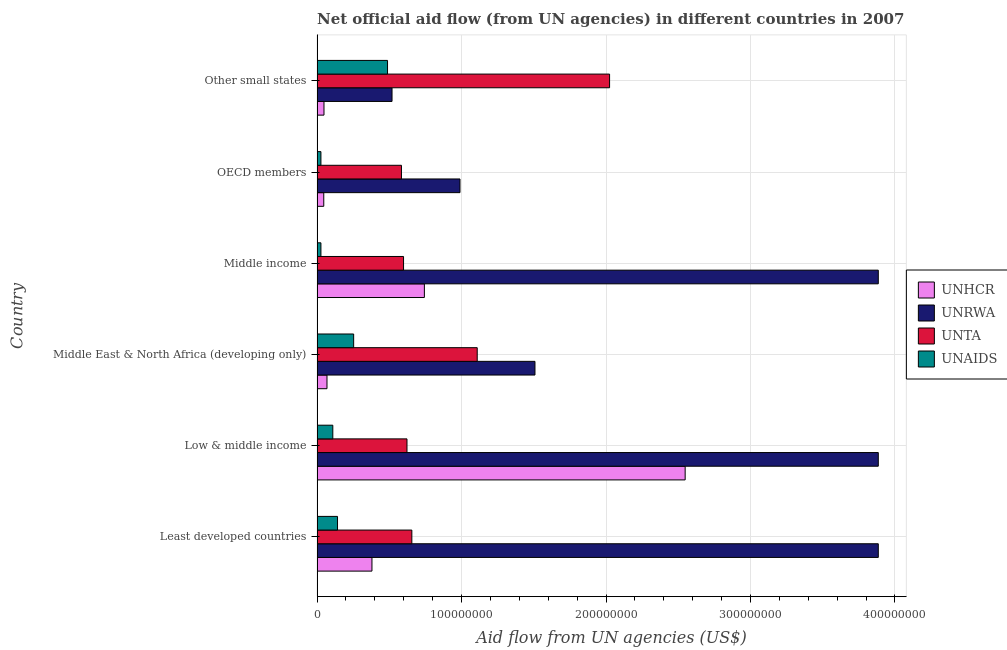How many different coloured bars are there?
Provide a short and direct response. 4. How many bars are there on the 4th tick from the top?
Your answer should be compact. 4. How many bars are there on the 6th tick from the bottom?
Provide a succinct answer. 4. What is the label of the 4th group of bars from the top?
Provide a short and direct response. Middle East & North Africa (developing only). What is the amount of aid given by unrwa in Low & middle income?
Provide a succinct answer. 3.88e+08. Across all countries, what is the maximum amount of aid given by unaids?
Give a very brief answer. 4.88e+07. Across all countries, what is the minimum amount of aid given by unta?
Your response must be concise. 5.84e+07. In which country was the amount of aid given by unrwa maximum?
Provide a short and direct response. Least developed countries. What is the total amount of aid given by unhcr in the graph?
Your response must be concise. 3.83e+08. What is the difference between the amount of aid given by unta in Middle East & North Africa (developing only) and that in Middle income?
Ensure brevity in your answer.  5.10e+07. What is the difference between the amount of aid given by unhcr in Low & middle income and the amount of aid given by unaids in Other small states?
Provide a succinct answer. 2.06e+08. What is the average amount of aid given by unta per country?
Provide a short and direct response. 9.32e+07. What is the difference between the amount of aid given by unta and amount of aid given by unrwa in Low & middle income?
Keep it short and to the point. -3.26e+08. What is the ratio of the amount of aid given by unrwa in Least developed countries to that in Middle income?
Your answer should be compact. 1. Is the difference between the amount of aid given by unrwa in Least developed countries and Middle income greater than the difference between the amount of aid given by unaids in Least developed countries and Middle income?
Give a very brief answer. No. What is the difference between the highest and the second highest amount of aid given by unaids?
Offer a terse response. 2.34e+07. What is the difference between the highest and the lowest amount of aid given by unaids?
Your answer should be very brief. 4.61e+07. Is it the case that in every country, the sum of the amount of aid given by unhcr and amount of aid given by unrwa is greater than the sum of amount of aid given by unaids and amount of aid given by unta?
Provide a succinct answer. Yes. What does the 3rd bar from the top in Middle East & North Africa (developing only) represents?
Give a very brief answer. UNRWA. What does the 2nd bar from the bottom in Least developed countries represents?
Provide a short and direct response. UNRWA. How many bars are there?
Offer a terse response. 24. Are the values on the major ticks of X-axis written in scientific E-notation?
Make the answer very short. No. Does the graph contain any zero values?
Keep it short and to the point. No. Where does the legend appear in the graph?
Your answer should be very brief. Center right. How many legend labels are there?
Make the answer very short. 4. How are the legend labels stacked?
Provide a succinct answer. Vertical. What is the title of the graph?
Make the answer very short. Net official aid flow (from UN agencies) in different countries in 2007. Does "Salary of employees" appear as one of the legend labels in the graph?
Ensure brevity in your answer.  No. What is the label or title of the X-axis?
Offer a terse response. Aid flow from UN agencies (US$). What is the label or title of the Y-axis?
Make the answer very short. Country. What is the Aid flow from UN agencies (US$) of UNHCR in Least developed countries?
Your response must be concise. 3.80e+07. What is the Aid flow from UN agencies (US$) in UNRWA in Least developed countries?
Provide a short and direct response. 3.88e+08. What is the Aid flow from UN agencies (US$) of UNTA in Least developed countries?
Your answer should be very brief. 6.56e+07. What is the Aid flow from UN agencies (US$) in UNAIDS in Least developed countries?
Offer a terse response. 1.42e+07. What is the Aid flow from UN agencies (US$) of UNHCR in Low & middle income?
Ensure brevity in your answer.  2.55e+08. What is the Aid flow from UN agencies (US$) in UNRWA in Low & middle income?
Your response must be concise. 3.88e+08. What is the Aid flow from UN agencies (US$) in UNTA in Low & middle income?
Your response must be concise. 6.22e+07. What is the Aid flow from UN agencies (US$) in UNAIDS in Low & middle income?
Provide a succinct answer. 1.09e+07. What is the Aid flow from UN agencies (US$) of UNHCR in Middle East & North Africa (developing only)?
Your answer should be compact. 6.87e+06. What is the Aid flow from UN agencies (US$) of UNRWA in Middle East & North Africa (developing only)?
Keep it short and to the point. 1.51e+08. What is the Aid flow from UN agencies (US$) in UNTA in Middle East & North Africa (developing only)?
Your response must be concise. 1.11e+08. What is the Aid flow from UN agencies (US$) in UNAIDS in Middle East & North Africa (developing only)?
Ensure brevity in your answer.  2.53e+07. What is the Aid flow from UN agencies (US$) in UNHCR in Middle income?
Provide a short and direct response. 7.43e+07. What is the Aid flow from UN agencies (US$) of UNRWA in Middle income?
Make the answer very short. 3.88e+08. What is the Aid flow from UN agencies (US$) in UNTA in Middle income?
Give a very brief answer. 5.99e+07. What is the Aid flow from UN agencies (US$) of UNAIDS in Middle income?
Keep it short and to the point. 2.68e+06. What is the Aid flow from UN agencies (US$) of UNHCR in OECD members?
Offer a very short reply. 4.65e+06. What is the Aid flow from UN agencies (US$) of UNRWA in OECD members?
Offer a terse response. 9.89e+07. What is the Aid flow from UN agencies (US$) of UNTA in OECD members?
Ensure brevity in your answer.  5.84e+07. What is the Aid flow from UN agencies (US$) of UNAIDS in OECD members?
Give a very brief answer. 2.68e+06. What is the Aid flow from UN agencies (US$) of UNHCR in Other small states?
Your answer should be compact. 4.80e+06. What is the Aid flow from UN agencies (US$) in UNRWA in Other small states?
Your answer should be compact. 5.19e+07. What is the Aid flow from UN agencies (US$) of UNTA in Other small states?
Offer a terse response. 2.02e+08. What is the Aid flow from UN agencies (US$) of UNAIDS in Other small states?
Your answer should be very brief. 4.88e+07. Across all countries, what is the maximum Aid flow from UN agencies (US$) in UNHCR?
Ensure brevity in your answer.  2.55e+08. Across all countries, what is the maximum Aid flow from UN agencies (US$) of UNRWA?
Your response must be concise. 3.88e+08. Across all countries, what is the maximum Aid flow from UN agencies (US$) in UNTA?
Provide a succinct answer. 2.02e+08. Across all countries, what is the maximum Aid flow from UN agencies (US$) of UNAIDS?
Your answer should be very brief. 4.88e+07. Across all countries, what is the minimum Aid flow from UN agencies (US$) in UNHCR?
Make the answer very short. 4.65e+06. Across all countries, what is the minimum Aid flow from UN agencies (US$) in UNRWA?
Give a very brief answer. 5.19e+07. Across all countries, what is the minimum Aid flow from UN agencies (US$) in UNTA?
Offer a terse response. 5.84e+07. Across all countries, what is the minimum Aid flow from UN agencies (US$) in UNAIDS?
Provide a succinct answer. 2.68e+06. What is the total Aid flow from UN agencies (US$) of UNHCR in the graph?
Offer a terse response. 3.83e+08. What is the total Aid flow from UN agencies (US$) in UNRWA in the graph?
Make the answer very short. 1.47e+09. What is the total Aid flow from UN agencies (US$) of UNTA in the graph?
Your answer should be compact. 5.59e+08. What is the total Aid flow from UN agencies (US$) of UNAIDS in the graph?
Provide a short and direct response. 1.05e+08. What is the difference between the Aid flow from UN agencies (US$) of UNHCR in Least developed countries and that in Low & middle income?
Make the answer very short. -2.17e+08. What is the difference between the Aid flow from UN agencies (US$) of UNRWA in Least developed countries and that in Low & middle income?
Your response must be concise. 0. What is the difference between the Aid flow from UN agencies (US$) of UNTA in Least developed countries and that in Low & middle income?
Offer a terse response. 3.37e+06. What is the difference between the Aid flow from UN agencies (US$) of UNAIDS in Least developed countries and that in Low & middle income?
Offer a very short reply. 3.25e+06. What is the difference between the Aid flow from UN agencies (US$) in UNHCR in Least developed countries and that in Middle East & North Africa (developing only)?
Ensure brevity in your answer.  3.11e+07. What is the difference between the Aid flow from UN agencies (US$) of UNRWA in Least developed countries and that in Middle East & North Africa (developing only)?
Make the answer very short. 2.38e+08. What is the difference between the Aid flow from UN agencies (US$) of UNTA in Least developed countries and that in Middle East & North Africa (developing only)?
Offer a very short reply. -4.52e+07. What is the difference between the Aid flow from UN agencies (US$) in UNAIDS in Least developed countries and that in Middle East & North Africa (developing only)?
Give a very brief answer. -1.12e+07. What is the difference between the Aid flow from UN agencies (US$) in UNHCR in Least developed countries and that in Middle income?
Keep it short and to the point. -3.63e+07. What is the difference between the Aid flow from UN agencies (US$) of UNRWA in Least developed countries and that in Middle income?
Give a very brief answer. 0. What is the difference between the Aid flow from UN agencies (US$) of UNTA in Least developed countries and that in Middle income?
Offer a terse response. 5.75e+06. What is the difference between the Aid flow from UN agencies (US$) in UNAIDS in Least developed countries and that in Middle income?
Make the answer very short. 1.15e+07. What is the difference between the Aid flow from UN agencies (US$) in UNHCR in Least developed countries and that in OECD members?
Ensure brevity in your answer.  3.34e+07. What is the difference between the Aid flow from UN agencies (US$) in UNRWA in Least developed countries and that in OECD members?
Provide a succinct answer. 2.90e+08. What is the difference between the Aid flow from UN agencies (US$) in UNTA in Least developed countries and that in OECD members?
Provide a short and direct response. 7.20e+06. What is the difference between the Aid flow from UN agencies (US$) of UNAIDS in Least developed countries and that in OECD members?
Provide a short and direct response. 1.15e+07. What is the difference between the Aid flow from UN agencies (US$) in UNHCR in Least developed countries and that in Other small states?
Make the answer very short. 3.32e+07. What is the difference between the Aid flow from UN agencies (US$) in UNRWA in Least developed countries and that in Other small states?
Your answer should be very brief. 3.37e+08. What is the difference between the Aid flow from UN agencies (US$) of UNTA in Least developed countries and that in Other small states?
Offer a terse response. -1.37e+08. What is the difference between the Aid flow from UN agencies (US$) in UNAIDS in Least developed countries and that in Other small states?
Your response must be concise. -3.46e+07. What is the difference between the Aid flow from UN agencies (US$) of UNHCR in Low & middle income and that in Middle East & North Africa (developing only)?
Provide a short and direct response. 2.48e+08. What is the difference between the Aid flow from UN agencies (US$) in UNRWA in Low & middle income and that in Middle East & North Africa (developing only)?
Offer a very short reply. 2.38e+08. What is the difference between the Aid flow from UN agencies (US$) of UNTA in Low & middle income and that in Middle East & North Africa (developing only)?
Make the answer very short. -4.86e+07. What is the difference between the Aid flow from UN agencies (US$) of UNAIDS in Low & middle income and that in Middle East & North Africa (developing only)?
Your answer should be compact. -1.44e+07. What is the difference between the Aid flow from UN agencies (US$) in UNHCR in Low & middle income and that in Middle income?
Your response must be concise. 1.80e+08. What is the difference between the Aid flow from UN agencies (US$) of UNRWA in Low & middle income and that in Middle income?
Provide a short and direct response. 0. What is the difference between the Aid flow from UN agencies (US$) of UNTA in Low & middle income and that in Middle income?
Provide a succinct answer. 2.38e+06. What is the difference between the Aid flow from UN agencies (US$) in UNAIDS in Low & middle income and that in Middle income?
Offer a very short reply. 8.23e+06. What is the difference between the Aid flow from UN agencies (US$) of UNHCR in Low & middle income and that in OECD members?
Your response must be concise. 2.50e+08. What is the difference between the Aid flow from UN agencies (US$) of UNRWA in Low & middle income and that in OECD members?
Offer a terse response. 2.90e+08. What is the difference between the Aid flow from UN agencies (US$) in UNTA in Low & middle income and that in OECD members?
Offer a very short reply. 3.83e+06. What is the difference between the Aid flow from UN agencies (US$) in UNAIDS in Low & middle income and that in OECD members?
Offer a terse response. 8.23e+06. What is the difference between the Aid flow from UN agencies (US$) in UNHCR in Low & middle income and that in Other small states?
Give a very brief answer. 2.50e+08. What is the difference between the Aid flow from UN agencies (US$) of UNRWA in Low & middle income and that in Other small states?
Give a very brief answer. 3.37e+08. What is the difference between the Aid flow from UN agencies (US$) of UNTA in Low & middle income and that in Other small states?
Your response must be concise. -1.40e+08. What is the difference between the Aid flow from UN agencies (US$) in UNAIDS in Low & middle income and that in Other small states?
Your answer should be very brief. -3.79e+07. What is the difference between the Aid flow from UN agencies (US$) of UNHCR in Middle East & North Africa (developing only) and that in Middle income?
Give a very brief answer. -6.74e+07. What is the difference between the Aid flow from UN agencies (US$) in UNRWA in Middle East & North Africa (developing only) and that in Middle income?
Provide a short and direct response. -2.38e+08. What is the difference between the Aid flow from UN agencies (US$) of UNTA in Middle East & North Africa (developing only) and that in Middle income?
Your answer should be very brief. 5.10e+07. What is the difference between the Aid flow from UN agencies (US$) of UNAIDS in Middle East & North Africa (developing only) and that in Middle income?
Provide a short and direct response. 2.26e+07. What is the difference between the Aid flow from UN agencies (US$) in UNHCR in Middle East & North Africa (developing only) and that in OECD members?
Your response must be concise. 2.22e+06. What is the difference between the Aid flow from UN agencies (US$) of UNRWA in Middle East & North Africa (developing only) and that in OECD members?
Make the answer very short. 5.19e+07. What is the difference between the Aid flow from UN agencies (US$) of UNTA in Middle East & North Africa (developing only) and that in OECD members?
Ensure brevity in your answer.  5.24e+07. What is the difference between the Aid flow from UN agencies (US$) of UNAIDS in Middle East & North Africa (developing only) and that in OECD members?
Offer a terse response. 2.26e+07. What is the difference between the Aid flow from UN agencies (US$) of UNHCR in Middle East & North Africa (developing only) and that in Other small states?
Offer a very short reply. 2.07e+06. What is the difference between the Aid flow from UN agencies (US$) in UNRWA in Middle East & North Africa (developing only) and that in Other small states?
Your answer should be compact. 9.89e+07. What is the difference between the Aid flow from UN agencies (US$) in UNTA in Middle East & North Africa (developing only) and that in Other small states?
Provide a short and direct response. -9.16e+07. What is the difference between the Aid flow from UN agencies (US$) of UNAIDS in Middle East & North Africa (developing only) and that in Other small states?
Give a very brief answer. -2.34e+07. What is the difference between the Aid flow from UN agencies (US$) in UNHCR in Middle income and that in OECD members?
Ensure brevity in your answer.  6.96e+07. What is the difference between the Aid flow from UN agencies (US$) of UNRWA in Middle income and that in OECD members?
Give a very brief answer. 2.90e+08. What is the difference between the Aid flow from UN agencies (US$) of UNTA in Middle income and that in OECD members?
Provide a short and direct response. 1.45e+06. What is the difference between the Aid flow from UN agencies (US$) of UNAIDS in Middle income and that in OECD members?
Provide a short and direct response. 0. What is the difference between the Aid flow from UN agencies (US$) of UNHCR in Middle income and that in Other small states?
Offer a very short reply. 6.95e+07. What is the difference between the Aid flow from UN agencies (US$) in UNRWA in Middle income and that in Other small states?
Give a very brief answer. 3.37e+08. What is the difference between the Aid flow from UN agencies (US$) of UNTA in Middle income and that in Other small states?
Ensure brevity in your answer.  -1.43e+08. What is the difference between the Aid flow from UN agencies (US$) of UNAIDS in Middle income and that in Other small states?
Provide a succinct answer. -4.61e+07. What is the difference between the Aid flow from UN agencies (US$) of UNHCR in OECD members and that in Other small states?
Your answer should be very brief. -1.50e+05. What is the difference between the Aid flow from UN agencies (US$) in UNRWA in OECD members and that in Other small states?
Give a very brief answer. 4.70e+07. What is the difference between the Aid flow from UN agencies (US$) of UNTA in OECD members and that in Other small states?
Your answer should be compact. -1.44e+08. What is the difference between the Aid flow from UN agencies (US$) of UNAIDS in OECD members and that in Other small states?
Give a very brief answer. -4.61e+07. What is the difference between the Aid flow from UN agencies (US$) of UNHCR in Least developed countries and the Aid flow from UN agencies (US$) of UNRWA in Low & middle income?
Provide a succinct answer. -3.50e+08. What is the difference between the Aid flow from UN agencies (US$) of UNHCR in Least developed countries and the Aid flow from UN agencies (US$) of UNTA in Low & middle income?
Make the answer very short. -2.42e+07. What is the difference between the Aid flow from UN agencies (US$) of UNHCR in Least developed countries and the Aid flow from UN agencies (US$) of UNAIDS in Low & middle income?
Offer a terse response. 2.71e+07. What is the difference between the Aid flow from UN agencies (US$) in UNRWA in Least developed countries and the Aid flow from UN agencies (US$) in UNTA in Low & middle income?
Ensure brevity in your answer.  3.26e+08. What is the difference between the Aid flow from UN agencies (US$) of UNRWA in Least developed countries and the Aid flow from UN agencies (US$) of UNAIDS in Low & middle income?
Offer a terse response. 3.78e+08. What is the difference between the Aid flow from UN agencies (US$) of UNTA in Least developed countries and the Aid flow from UN agencies (US$) of UNAIDS in Low & middle income?
Give a very brief answer. 5.47e+07. What is the difference between the Aid flow from UN agencies (US$) in UNHCR in Least developed countries and the Aid flow from UN agencies (US$) in UNRWA in Middle East & North Africa (developing only)?
Offer a terse response. -1.13e+08. What is the difference between the Aid flow from UN agencies (US$) of UNHCR in Least developed countries and the Aid flow from UN agencies (US$) of UNTA in Middle East & North Africa (developing only)?
Offer a terse response. -7.28e+07. What is the difference between the Aid flow from UN agencies (US$) of UNHCR in Least developed countries and the Aid flow from UN agencies (US$) of UNAIDS in Middle East & North Africa (developing only)?
Offer a terse response. 1.27e+07. What is the difference between the Aid flow from UN agencies (US$) in UNRWA in Least developed countries and the Aid flow from UN agencies (US$) in UNTA in Middle East & North Africa (developing only)?
Provide a succinct answer. 2.78e+08. What is the difference between the Aid flow from UN agencies (US$) in UNRWA in Least developed countries and the Aid flow from UN agencies (US$) in UNAIDS in Middle East & North Africa (developing only)?
Provide a succinct answer. 3.63e+08. What is the difference between the Aid flow from UN agencies (US$) in UNTA in Least developed countries and the Aid flow from UN agencies (US$) in UNAIDS in Middle East & North Africa (developing only)?
Provide a succinct answer. 4.03e+07. What is the difference between the Aid flow from UN agencies (US$) of UNHCR in Least developed countries and the Aid flow from UN agencies (US$) of UNRWA in Middle income?
Provide a short and direct response. -3.50e+08. What is the difference between the Aid flow from UN agencies (US$) of UNHCR in Least developed countries and the Aid flow from UN agencies (US$) of UNTA in Middle income?
Provide a succinct answer. -2.19e+07. What is the difference between the Aid flow from UN agencies (US$) of UNHCR in Least developed countries and the Aid flow from UN agencies (US$) of UNAIDS in Middle income?
Your response must be concise. 3.53e+07. What is the difference between the Aid flow from UN agencies (US$) in UNRWA in Least developed countries and the Aid flow from UN agencies (US$) in UNTA in Middle income?
Your answer should be compact. 3.29e+08. What is the difference between the Aid flow from UN agencies (US$) of UNRWA in Least developed countries and the Aid flow from UN agencies (US$) of UNAIDS in Middle income?
Your response must be concise. 3.86e+08. What is the difference between the Aid flow from UN agencies (US$) in UNTA in Least developed countries and the Aid flow from UN agencies (US$) in UNAIDS in Middle income?
Ensure brevity in your answer.  6.29e+07. What is the difference between the Aid flow from UN agencies (US$) in UNHCR in Least developed countries and the Aid flow from UN agencies (US$) in UNRWA in OECD members?
Give a very brief answer. -6.09e+07. What is the difference between the Aid flow from UN agencies (US$) of UNHCR in Least developed countries and the Aid flow from UN agencies (US$) of UNTA in OECD members?
Offer a very short reply. -2.04e+07. What is the difference between the Aid flow from UN agencies (US$) in UNHCR in Least developed countries and the Aid flow from UN agencies (US$) in UNAIDS in OECD members?
Give a very brief answer. 3.53e+07. What is the difference between the Aid flow from UN agencies (US$) of UNRWA in Least developed countries and the Aid flow from UN agencies (US$) of UNTA in OECD members?
Keep it short and to the point. 3.30e+08. What is the difference between the Aid flow from UN agencies (US$) in UNRWA in Least developed countries and the Aid flow from UN agencies (US$) in UNAIDS in OECD members?
Ensure brevity in your answer.  3.86e+08. What is the difference between the Aid flow from UN agencies (US$) of UNTA in Least developed countries and the Aid flow from UN agencies (US$) of UNAIDS in OECD members?
Your answer should be very brief. 6.29e+07. What is the difference between the Aid flow from UN agencies (US$) in UNHCR in Least developed countries and the Aid flow from UN agencies (US$) in UNRWA in Other small states?
Offer a terse response. -1.39e+07. What is the difference between the Aid flow from UN agencies (US$) of UNHCR in Least developed countries and the Aid flow from UN agencies (US$) of UNTA in Other small states?
Ensure brevity in your answer.  -1.64e+08. What is the difference between the Aid flow from UN agencies (US$) in UNHCR in Least developed countries and the Aid flow from UN agencies (US$) in UNAIDS in Other small states?
Provide a short and direct response. -1.08e+07. What is the difference between the Aid flow from UN agencies (US$) in UNRWA in Least developed countries and the Aid flow from UN agencies (US$) in UNTA in Other small states?
Provide a short and direct response. 1.86e+08. What is the difference between the Aid flow from UN agencies (US$) of UNRWA in Least developed countries and the Aid flow from UN agencies (US$) of UNAIDS in Other small states?
Your response must be concise. 3.40e+08. What is the difference between the Aid flow from UN agencies (US$) in UNTA in Least developed countries and the Aid flow from UN agencies (US$) in UNAIDS in Other small states?
Offer a terse response. 1.68e+07. What is the difference between the Aid flow from UN agencies (US$) of UNHCR in Low & middle income and the Aid flow from UN agencies (US$) of UNRWA in Middle East & North Africa (developing only)?
Your answer should be compact. 1.04e+08. What is the difference between the Aid flow from UN agencies (US$) of UNHCR in Low & middle income and the Aid flow from UN agencies (US$) of UNTA in Middle East & North Africa (developing only)?
Your answer should be compact. 1.44e+08. What is the difference between the Aid flow from UN agencies (US$) in UNHCR in Low & middle income and the Aid flow from UN agencies (US$) in UNAIDS in Middle East & North Africa (developing only)?
Your answer should be very brief. 2.29e+08. What is the difference between the Aid flow from UN agencies (US$) in UNRWA in Low & middle income and the Aid flow from UN agencies (US$) in UNTA in Middle East & North Africa (developing only)?
Offer a very short reply. 2.78e+08. What is the difference between the Aid flow from UN agencies (US$) in UNRWA in Low & middle income and the Aid flow from UN agencies (US$) in UNAIDS in Middle East & North Africa (developing only)?
Your response must be concise. 3.63e+08. What is the difference between the Aid flow from UN agencies (US$) of UNTA in Low & middle income and the Aid flow from UN agencies (US$) of UNAIDS in Middle East & North Africa (developing only)?
Offer a terse response. 3.69e+07. What is the difference between the Aid flow from UN agencies (US$) of UNHCR in Low & middle income and the Aid flow from UN agencies (US$) of UNRWA in Middle income?
Provide a succinct answer. -1.34e+08. What is the difference between the Aid flow from UN agencies (US$) in UNHCR in Low & middle income and the Aid flow from UN agencies (US$) in UNTA in Middle income?
Make the answer very short. 1.95e+08. What is the difference between the Aid flow from UN agencies (US$) in UNHCR in Low & middle income and the Aid flow from UN agencies (US$) in UNAIDS in Middle income?
Offer a terse response. 2.52e+08. What is the difference between the Aid flow from UN agencies (US$) in UNRWA in Low & middle income and the Aid flow from UN agencies (US$) in UNTA in Middle income?
Provide a succinct answer. 3.29e+08. What is the difference between the Aid flow from UN agencies (US$) of UNRWA in Low & middle income and the Aid flow from UN agencies (US$) of UNAIDS in Middle income?
Offer a terse response. 3.86e+08. What is the difference between the Aid flow from UN agencies (US$) in UNTA in Low & middle income and the Aid flow from UN agencies (US$) in UNAIDS in Middle income?
Provide a short and direct response. 5.96e+07. What is the difference between the Aid flow from UN agencies (US$) in UNHCR in Low & middle income and the Aid flow from UN agencies (US$) in UNRWA in OECD members?
Offer a terse response. 1.56e+08. What is the difference between the Aid flow from UN agencies (US$) of UNHCR in Low & middle income and the Aid flow from UN agencies (US$) of UNTA in OECD members?
Provide a short and direct response. 1.96e+08. What is the difference between the Aid flow from UN agencies (US$) of UNHCR in Low & middle income and the Aid flow from UN agencies (US$) of UNAIDS in OECD members?
Offer a very short reply. 2.52e+08. What is the difference between the Aid flow from UN agencies (US$) of UNRWA in Low & middle income and the Aid flow from UN agencies (US$) of UNTA in OECD members?
Your answer should be compact. 3.30e+08. What is the difference between the Aid flow from UN agencies (US$) of UNRWA in Low & middle income and the Aid flow from UN agencies (US$) of UNAIDS in OECD members?
Provide a succinct answer. 3.86e+08. What is the difference between the Aid flow from UN agencies (US$) of UNTA in Low & middle income and the Aid flow from UN agencies (US$) of UNAIDS in OECD members?
Ensure brevity in your answer.  5.96e+07. What is the difference between the Aid flow from UN agencies (US$) of UNHCR in Low & middle income and the Aid flow from UN agencies (US$) of UNRWA in Other small states?
Keep it short and to the point. 2.03e+08. What is the difference between the Aid flow from UN agencies (US$) of UNHCR in Low & middle income and the Aid flow from UN agencies (US$) of UNTA in Other small states?
Your answer should be very brief. 5.23e+07. What is the difference between the Aid flow from UN agencies (US$) in UNHCR in Low & middle income and the Aid flow from UN agencies (US$) in UNAIDS in Other small states?
Give a very brief answer. 2.06e+08. What is the difference between the Aid flow from UN agencies (US$) of UNRWA in Low & middle income and the Aid flow from UN agencies (US$) of UNTA in Other small states?
Make the answer very short. 1.86e+08. What is the difference between the Aid flow from UN agencies (US$) of UNRWA in Low & middle income and the Aid flow from UN agencies (US$) of UNAIDS in Other small states?
Provide a short and direct response. 3.40e+08. What is the difference between the Aid flow from UN agencies (US$) in UNTA in Low & middle income and the Aid flow from UN agencies (US$) in UNAIDS in Other small states?
Make the answer very short. 1.35e+07. What is the difference between the Aid flow from UN agencies (US$) of UNHCR in Middle East & North Africa (developing only) and the Aid flow from UN agencies (US$) of UNRWA in Middle income?
Ensure brevity in your answer.  -3.82e+08. What is the difference between the Aid flow from UN agencies (US$) of UNHCR in Middle East & North Africa (developing only) and the Aid flow from UN agencies (US$) of UNTA in Middle income?
Keep it short and to the point. -5.30e+07. What is the difference between the Aid flow from UN agencies (US$) in UNHCR in Middle East & North Africa (developing only) and the Aid flow from UN agencies (US$) in UNAIDS in Middle income?
Make the answer very short. 4.19e+06. What is the difference between the Aid flow from UN agencies (US$) in UNRWA in Middle East & North Africa (developing only) and the Aid flow from UN agencies (US$) in UNTA in Middle income?
Provide a short and direct response. 9.10e+07. What is the difference between the Aid flow from UN agencies (US$) of UNRWA in Middle East & North Africa (developing only) and the Aid flow from UN agencies (US$) of UNAIDS in Middle income?
Keep it short and to the point. 1.48e+08. What is the difference between the Aid flow from UN agencies (US$) in UNTA in Middle East & North Africa (developing only) and the Aid flow from UN agencies (US$) in UNAIDS in Middle income?
Provide a succinct answer. 1.08e+08. What is the difference between the Aid flow from UN agencies (US$) of UNHCR in Middle East & North Africa (developing only) and the Aid flow from UN agencies (US$) of UNRWA in OECD members?
Provide a succinct answer. -9.21e+07. What is the difference between the Aid flow from UN agencies (US$) in UNHCR in Middle East & North Africa (developing only) and the Aid flow from UN agencies (US$) in UNTA in OECD members?
Give a very brief answer. -5.15e+07. What is the difference between the Aid flow from UN agencies (US$) of UNHCR in Middle East & North Africa (developing only) and the Aid flow from UN agencies (US$) of UNAIDS in OECD members?
Give a very brief answer. 4.19e+06. What is the difference between the Aid flow from UN agencies (US$) of UNRWA in Middle East & North Africa (developing only) and the Aid flow from UN agencies (US$) of UNTA in OECD members?
Keep it short and to the point. 9.24e+07. What is the difference between the Aid flow from UN agencies (US$) in UNRWA in Middle East & North Africa (developing only) and the Aid flow from UN agencies (US$) in UNAIDS in OECD members?
Provide a short and direct response. 1.48e+08. What is the difference between the Aid flow from UN agencies (US$) of UNTA in Middle East & North Africa (developing only) and the Aid flow from UN agencies (US$) of UNAIDS in OECD members?
Ensure brevity in your answer.  1.08e+08. What is the difference between the Aid flow from UN agencies (US$) of UNHCR in Middle East & North Africa (developing only) and the Aid flow from UN agencies (US$) of UNRWA in Other small states?
Give a very brief answer. -4.50e+07. What is the difference between the Aid flow from UN agencies (US$) in UNHCR in Middle East & North Africa (developing only) and the Aid flow from UN agencies (US$) in UNTA in Other small states?
Your response must be concise. -1.96e+08. What is the difference between the Aid flow from UN agencies (US$) of UNHCR in Middle East & North Africa (developing only) and the Aid flow from UN agencies (US$) of UNAIDS in Other small states?
Your response must be concise. -4.19e+07. What is the difference between the Aid flow from UN agencies (US$) in UNRWA in Middle East & North Africa (developing only) and the Aid flow from UN agencies (US$) in UNTA in Other small states?
Give a very brief answer. -5.16e+07. What is the difference between the Aid flow from UN agencies (US$) in UNRWA in Middle East & North Africa (developing only) and the Aid flow from UN agencies (US$) in UNAIDS in Other small states?
Your answer should be very brief. 1.02e+08. What is the difference between the Aid flow from UN agencies (US$) in UNTA in Middle East & North Africa (developing only) and the Aid flow from UN agencies (US$) in UNAIDS in Other small states?
Your answer should be compact. 6.21e+07. What is the difference between the Aid flow from UN agencies (US$) of UNHCR in Middle income and the Aid flow from UN agencies (US$) of UNRWA in OECD members?
Your response must be concise. -2.46e+07. What is the difference between the Aid flow from UN agencies (US$) of UNHCR in Middle income and the Aid flow from UN agencies (US$) of UNTA in OECD members?
Provide a short and direct response. 1.59e+07. What is the difference between the Aid flow from UN agencies (US$) in UNHCR in Middle income and the Aid flow from UN agencies (US$) in UNAIDS in OECD members?
Give a very brief answer. 7.16e+07. What is the difference between the Aid flow from UN agencies (US$) in UNRWA in Middle income and the Aid flow from UN agencies (US$) in UNTA in OECD members?
Ensure brevity in your answer.  3.30e+08. What is the difference between the Aid flow from UN agencies (US$) in UNRWA in Middle income and the Aid flow from UN agencies (US$) in UNAIDS in OECD members?
Offer a very short reply. 3.86e+08. What is the difference between the Aid flow from UN agencies (US$) in UNTA in Middle income and the Aid flow from UN agencies (US$) in UNAIDS in OECD members?
Your response must be concise. 5.72e+07. What is the difference between the Aid flow from UN agencies (US$) in UNHCR in Middle income and the Aid flow from UN agencies (US$) in UNRWA in Other small states?
Keep it short and to the point. 2.24e+07. What is the difference between the Aid flow from UN agencies (US$) in UNHCR in Middle income and the Aid flow from UN agencies (US$) in UNTA in Other small states?
Give a very brief answer. -1.28e+08. What is the difference between the Aid flow from UN agencies (US$) in UNHCR in Middle income and the Aid flow from UN agencies (US$) in UNAIDS in Other small states?
Your answer should be compact. 2.55e+07. What is the difference between the Aid flow from UN agencies (US$) of UNRWA in Middle income and the Aid flow from UN agencies (US$) of UNTA in Other small states?
Ensure brevity in your answer.  1.86e+08. What is the difference between the Aid flow from UN agencies (US$) of UNRWA in Middle income and the Aid flow from UN agencies (US$) of UNAIDS in Other small states?
Your response must be concise. 3.40e+08. What is the difference between the Aid flow from UN agencies (US$) of UNTA in Middle income and the Aid flow from UN agencies (US$) of UNAIDS in Other small states?
Give a very brief answer. 1.11e+07. What is the difference between the Aid flow from UN agencies (US$) in UNHCR in OECD members and the Aid flow from UN agencies (US$) in UNRWA in Other small states?
Give a very brief answer. -4.72e+07. What is the difference between the Aid flow from UN agencies (US$) of UNHCR in OECD members and the Aid flow from UN agencies (US$) of UNTA in Other small states?
Your answer should be compact. -1.98e+08. What is the difference between the Aid flow from UN agencies (US$) of UNHCR in OECD members and the Aid flow from UN agencies (US$) of UNAIDS in Other small states?
Provide a succinct answer. -4.41e+07. What is the difference between the Aid flow from UN agencies (US$) of UNRWA in OECD members and the Aid flow from UN agencies (US$) of UNTA in Other small states?
Ensure brevity in your answer.  -1.04e+08. What is the difference between the Aid flow from UN agencies (US$) in UNRWA in OECD members and the Aid flow from UN agencies (US$) in UNAIDS in Other small states?
Provide a succinct answer. 5.02e+07. What is the difference between the Aid flow from UN agencies (US$) of UNTA in OECD members and the Aid flow from UN agencies (US$) of UNAIDS in Other small states?
Your response must be concise. 9.63e+06. What is the average Aid flow from UN agencies (US$) in UNHCR per country?
Your answer should be compact. 6.39e+07. What is the average Aid flow from UN agencies (US$) of UNRWA per country?
Provide a short and direct response. 2.44e+08. What is the average Aid flow from UN agencies (US$) in UNTA per country?
Offer a very short reply. 9.32e+07. What is the average Aid flow from UN agencies (US$) of UNAIDS per country?
Your answer should be very brief. 1.74e+07. What is the difference between the Aid flow from UN agencies (US$) in UNHCR and Aid flow from UN agencies (US$) in UNRWA in Least developed countries?
Your response must be concise. -3.50e+08. What is the difference between the Aid flow from UN agencies (US$) of UNHCR and Aid flow from UN agencies (US$) of UNTA in Least developed countries?
Ensure brevity in your answer.  -2.76e+07. What is the difference between the Aid flow from UN agencies (US$) of UNHCR and Aid flow from UN agencies (US$) of UNAIDS in Least developed countries?
Offer a terse response. 2.38e+07. What is the difference between the Aid flow from UN agencies (US$) of UNRWA and Aid flow from UN agencies (US$) of UNTA in Least developed countries?
Give a very brief answer. 3.23e+08. What is the difference between the Aid flow from UN agencies (US$) in UNRWA and Aid flow from UN agencies (US$) in UNAIDS in Least developed countries?
Offer a terse response. 3.74e+08. What is the difference between the Aid flow from UN agencies (US$) of UNTA and Aid flow from UN agencies (US$) of UNAIDS in Least developed countries?
Your response must be concise. 5.14e+07. What is the difference between the Aid flow from UN agencies (US$) in UNHCR and Aid flow from UN agencies (US$) in UNRWA in Low & middle income?
Offer a terse response. -1.34e+08. What is the difference between the Aid flow from UN agencies (US$) of UNHCR and Aid flow from UN agencies (US$) of UNTA in Low & middle income?
Your answer should be compact. 1.93e+08. What is the difference between the Aid flow from UN agencies (US$) of UNHCR and Aid flow from UN agencies (US$) of UNAIDS in Low & middle income?
Provide a short and direct response. 2.44e+08. What is the difference between the Aid flow from UN agencies (US$) in UNRWA and Aid flow from UN agencies (US$) in UNTA in Low & middle income?
Offer a terse response. 3.26e+08. What is the difference between the Aid flow from UN agencies (US$) in UNRWA and Aid flow from UN agencies (US$) in UNAIDS in Low & middle income?
Offer a very short reply. 3.78e+08. What is the difference between the Aid flow from UN agencies (US$) in UNTA and Aid flow from UN agencies (US$) in UNAIDS in Low & middle income?
Your response must be concise. 5.13e+07. What is the difference between the Aid flow from UN agencies (US$) of UNHCR and Aid flow from UN agencies (US$) of UNRWA in Middle East & North Africa (developing only)?
Give a very brief answer. -1.44e+08. What is the difference between the Aid flow from UN agencies (US$) of UNHCR and Aid flow from UN agencies (US$) of UNTA in Middle East & North Africa (developing only)?
Offer a terse response. -1.04e+08. What is the difference between the Aid flow from UN agencies (US$) in UNHCR and Aid flow from UN agencies (US$) in UNAIDS in Middle East & North Africa (developing only)?
Your answer should be very brief. -1.85e+07. What is the difference between the Aid flow from UN agencies (US$) of UNRWA and Aid flow from UN agencies (US$) of UNTA in Middle East & North Africa (developing only)?
Keep it short and to the point. 4.00e+07. What is the difference between the Aid flow from UN agencies (US$) of UNRWA and Aid flow from UN agencies (US$) of UNAIDS in Middle East & North Africa (developing only)?
Provide a succinct answer. 1.25e+08. What is the difference between the Aid flow from UN agencies (US$) in UNTA and Aid flow from UN agencies (US$) in UNAIDS in Middle East & North Africa (developing only)?
Give a very brief answer. 8.55e+07. What is the difference between the Aid flow from UN agencies (US$) of UNHCR and Aid flow from UN agencies (US$) of UNRWA in Middle income?
Provide a short and direct response. -3.14e+08. What is the difference between the Aid flow from UN agencies (US$) of UNHCR and Aid flow from UN agencies (US$) of UNTA in Middle income?
Your response must be concise. 1.44e+07. What is the difference between the Aid flow from UN agencies (US$) of UNHCR and Aid flow from UN agencies (US$) of UNAIDS in Middle income?
Offer a terse response. 7.16e+07. What is the difference between the Aid flow from UN agencies (US$) in UNRWA and Aid flow from UN agencies (US$) in UNTA in Middle income?
Make the answer very short. 3.29e+08. What is the difference between the Aid flow from UN agencies (US$) of UNRWA and Aid flow from UN agencies (US$) of UNAIDS in Middle income?
Ensure brevity in your answer.  3.86e+08. What is the difference between the Aid flow from UN agencies (US$) of UNTA and Aid flow from UN agencies (US$) of UNAIDS in Middle income?
Your answer should be very brief. 5.72e+07. What is the difference between the Aid flow from UN agencies (US$) in UNHCR and Aid flow from UN agencies (US$) in UNRWA in OECD members?
Ensure brevity in your answer.  -9.43e+07. What is the difference between the Aid flow from UN agencies (US$) in UNHCR and Aid flow from UN agencies (US$) in UNTA in OECD members?
Provide a succinct answer. -5.38e+07. What is the difference between the Aid flow from UN agencies (US$) of UNHCR and Aid flow from UN agencies (US$) of UNAIDS in OECD members?
Give a very brief answer. 1.97e+06. What is the difference between the Aid flow from UN agencies (US$) of UNRWA and Aid flow from UN agencies (US$) of UNTA in OECD members?
Provide a succinct answer. 4.05e+07. What is the difference between the Aid flow from UN agencies (US$) in UNRWA and Aid flow from UN agencies (US$) in UNAIDS in OECD members?
Offer a very short reply. 9.62e+07. What is the difference between the Aid flow from UN agencies (US$) of UNTA and Aid flow from UN agencies (US$) of UNAIDS in OECD members?
Give a very brief answer. 5.57e+07. What is the difference between the Aid flow from UN agencies (US$) in UNHCR and Aid flow from UN agencies (US$) in UNRWA in Other small states?
Your response must be concise. -4.71e+07. What is the difference between the Aid flow from UN agencies (US$) of UNHCR and Aid flow from UN agencies (US$) of UNTA in Other small states?
Keep it short and to the point. -1.98e+08. What is the difference between the Aid flow from UN agencies (US$) of UNHCR and Aid flow from UN agencies (US$) of UNAIDS in Other small states?
Your answer should be compact. -4.40e+07. What is the difference between the Aid flow from UN agencies (US$) of UNRWA and Aid flow from UN agencies (US$) of UNTA in Other small states?
Offer a terse response. -1.51e+08. What is the difference between the Aid flow from UN agencies (US$) of UNRWA and Aid flow from UN agencies (US$) of UNAIDS in Other small states?
Keep it short and to the point. 3.11e+06. What is the difference between the Aid flow from UN agencies (US$) of UNTA and Aid flow from UN agencies (US$) of UNAIDS in Other small states?
Give a very brief answer. 1.54e+08. What is the ratio of the Aid flow from UN agencies (US$) of UNHCR in Least developed countries to that in Low & middle income?
Your response must be concise. 0.15. What is the ratio of the Aid flow from UN agencies (US$) in UNRWA in Least developed countries to that in Low & middle income?
Keep it short and to the point. 1. What is the ratio of the Aid flow from UN agencies (US$) of UNTA in Least developed countries to that in Low & middle income?
Make the answer very short. 1.05. What is the ratio of the Aid flow from UN agencies (US$) in UNAIDS in Least developed countries to that in Low & middle income?
Give a very brief answer. 1.3. What is the ratio of the Aid flow from UN agencies (US$) in UNHCR in Least developed countries to that in Middle East & North Africa (developing only)?
Ensure brevity in your answer.  5.53. What is the ratio of the Aid flow from UN agencies (US$) in UNRWA in Least developed countries to that in Middle East & North Africa (developing only)?
Offer a terse response. 2.58. What is the ratio of the Aid flow from UN agencies (US$) in UNTA in Least developed countries to that in Middle East & North Africa (developing only)?
Give a very brief answer. 0.59. What is the ratio of the Aid flow from UN agencies (US$) of UNAIDS in Least developed countries to that in Middle East & North Africa (developing only)?
Your answer should be very brief. 0.56. What is the ratio of the Aid flow from UN agencies (US$) of UNHCR in Least developed countries to that in Middle income?
Your answer should be compact. 0.51. What is the ratio of the Aid flow from UN agencies (US$) of UNTA in Least developed countries to that in Middle income?
Your answer should be compact. 1.1. What is the ratio of the Aid flow from UN agencies (US$) in UNAIDS in Least developed countries to that in Middle income?
Your response must be concise. 5.28. What is the ratio of the Aid flow from UN agencies (US$) of UNHCR in Least developed countries to that in OECD members?
Provide a short and direct response. 8.17. What is the ratio of the Aid flow from UN agencies (US$) in UNRWA in Least developed countries to that in OECD members?
Offer a very short reply. 3.93. What is the ratio of the Aid flow from UN agencies (US$) in UNTA in Least developed countries to that in OECD members?
Offer a very short reply. 1.12. What is the ratio of the Aid flow from UN agencies (US$) of UNAIDS in Least developed countries to that in OECD members?
Your answer should be very brief. 5.28. What is the ratio of the Aid flow from UN agencies (US$) of UNHCR in Least developed countries to that in Other small states?
Your response must be concise. 7.92. What is the ratio of the Aid flow from UN agencies (US$) of UNRWA in Least developed countries to that in Other small states?
Your response must be concise. 7.49. What is the ratio of the Aid flow from UN agencies (US$) in UNTA in Least developed countries to that in Other small states?
Ensure brevity in your answer.  0.32. What is the ratio of the Aid flow from UN agencies (US$) in UNAIDS in Least developed countries to that in Other small states?
Provide a succinct answer. 0.29. What is the ratio of the Aid flow from UN agencies (US$) in UNHCR in Low & middle income to that in Middle East & North Africa (developing only)?
Ensure brevity in your answer.  37.08. What is the ratio of the Aid flow from UN agencies (US$) of UNRWA in Low & middle income to that in Middle East & North Africa (developing only)?
Ensure brevity in your answer.  2.58. What is the ratio of the Aid flow from UN agencies (US$) of UNTA in Low & middle income to that in Middle East & North Africa (developing only)?
Provide a short and direct response. 0.56. What is the ratio of the Aid flow from UN agencies (US$) in UNAIDS in Low & middle income to that in Middle East & North Africa (developing only)?
Keep it short and to the point. 0.43. What is the ratio of the Aid flow from UN agencies (US$) of UNHCR in Low & middle income to that in Middle income?
Make the answer very short. 3.43. What is the ratio of the Aid flow from UN agencies (US$) of UNTA in Low & middle income to that in Middle income?
Provide a short and direct response. 1.04. What is the ratio of the Aid flow from UN agencies (US$) in UNAIDS in Low & middle income to that in Middle income?
Your response must be concise. 4.07. What is the ratio of the Aid flow from UN agencies (US$) of UNHCR in Low & middle income to that in OECD members?
Provide a succinct answer. 54.79. What is the ratio of the Aid flow from UN agencies (US$) in UNRWA in Low & middle income to that in OECD members?
Provide a succinct answer. 3.93. What is the ratio of the Aid flow from UN agencies (US$) in UNTA in Low & middle income to that in OECD members?
Provide a succinct answer. 1.07. What is the ratio of the Aid flow from UN agencies (US$) of UNAIDS in Low & middle income to that in OECD members?
Give a very brief answer. 4.07. What is the ratio of the Aid flow from UN agencies (US$) of UNHCR in Low & middle income to that in Other small states?
Your response must be concise. 53.08. What is the ratio of the Aid flow from UN agencies (US$) of UNRWA in Low & middle income to that in Other small states?
Provide a short and direct response. 7.49. What is the ratio of the Aid flow from UN agencies (US$) of UNTA in Low & middle income to that in Other small states?
Give a very brief answer. 0.31. What is the ratio of the Aid flow from UN agencies (US$) in UNAIDS in Low & middle income to that in Other small states?
Provide a succinct answer. 0.22. What is the ratio of the Aid flow from UN agencies (US$) of UNHCR in Middle East & North Africa (developing only) to that in Middle income?
Ensure brevity in your answer.  0.09. What is the ratio of the Aid flow from UN agencies (US$) of UNRWA in Middle East & North Africa (developing only) to that in Middle income?
Make the answer very short. 0.39. What is the ratio of the Aid flow from UN agencies (US$) in UNTA in Middle East & North Africa (developing only) to that in Middle income?
Provide a succinct answer. 1.85. What is the ratio of the Aid flow from UN agencies (US$) of UNAIDS in Middle East & North Africa (developing only) to that in Middle income?
Keep it short and to the point. 9.45. What is the ratio of the Aid flow from UN agencies (US$) in UNHCR in Middle East & North Africa (developing only) to that in OECD members?
Your answer should be compact. 1.48. What is the ratio of the Aid flow from UN agencies (US$) in UNRWA in Middle East & North Africa (developing only) to that in OECD members?
Make the answer very short. 1.52. What is the ratio of the Aid flow from UN agencies (US$) in UNTA in Middle East & North Africa (developing only) to that in OECD members?
Offer a very short reply. 1.9. What is the ratio of the Aid flow from UN agencies (US$) of UNAIDS in Middle East & North Africa (developing only) to that in OECD members?
Your response must be concise. 9.45. What is the ratio of the Aid flow from UN agencies (US$) in UNHCR in Middle East & North Africa (developing only) to that in Other small states?
Provide a succinct answer. 1.43. What is the ratio of the Aid flow from UN agencies (US$) of UNRWA in Middle East & North Africa (developing only) to that in Other small states?
Provide a succinct answer. 2.91. What is the ratio of the Aid flow from UN agencies (US$) of UNTA in Middle East & North Africa (developing only) to that in Other small states?
Your answer should be very brief. 0.55. What is the ratio of the Aid flow from UN agencies (US$) in UNAIDS in Middle East & North Africa (developing only) to that in Other small states?
Provide a short and direct response. 0.52. What is the ratio of the Aid flow from UN agencies (US$) of UNHCR in Middle income to that in OECD members?
Your answer should be very brief. 15.97. What is the ratio of the Aid flow from UN agencies (US$) in UNRWA in Middle income to that in OECD members?
Provide a succinct answer. 3.93. What is the ratio of the Aid flow from UN agencies (US$) in UNTA in Middle income to that in OECD members?
Offer a terse response. 1.02. What is the ratio of the Aid flow from UN agencies (US$) in UNAIDS in Middle income to that in OECD members?
Offer a terse response. 1. What is the ratio of the Aid flow from UN agencies (US$) in UNHCR in Middle income to that in Other small states?
Make the answer very short. 15.47. What is the ratio of the Aid flow from UN agencies (US$) of UNRWA in Middle income to that in Other small states?
Give a very brief answer. 7.49. What is the ratio of the Aid flow from UN agencies (US$) in UNTA in Middle income to that in Other small states?
Provide a succinct answer. 0.3. What is the ratio of the Aid flow from UN agencies (US$) in UNAIDS in Middle income to that in Other small states?
Provide a succinct answer. 0.05. What is the ratio of the Aid flow from UN agencies (US$) in UNHCR in OECD members to that in Other small states?
Give a very brief answer. 0.97. What is the ratio of the Aid flow from UN agencies (US$) in UNRWA in OECD members to that in Other small states?
Offer a terse response. 1.91. What is the ratio of the Aid flow from UN agencies (US$) in UNTA in OECD members to that in Other small states?
Ensure brevity in your answer.  0.29. What is the ratio of the Aid flow from UN agencies (US$) of UNAIDS in OECD members to that in Other small states?
Keep it short and to the point. 0.05. What is the difference between the highest and the second highest Aid flow from UN agencies (US$) in UNHCR?
Offer a terse response. 1.80e+08. What is the difference between the highest and the second highest Aid flow from UN agencies (US$) of UNTA?
Your response must be concise. 9.16e+07. What is the difference between the highest and the second highest Aid flow from UN agencies (US$) of UNAIDS?
Make the answer very short. 2.34e+07. What is the difference between the highest and the lowest Aid flow from UN agencies (US$) of UNHCR?
Ensure brevity in your answer.  2.50e+08. What is the difference between the highest and the lowest Aid flow from UN agencies (US$) in UNRWA?
Your response must be concise. 3.37e+08. What is the difference between the highest and the lowest Aid flow from UN agencies (US$) of UNTA?
Provide a succinct answer. 1.44e+08. What is the difference between the highest and the lowest Aid flow from UN agencies (US$) in UNAIDS?
Your response must be concise. 4.61e+07. 